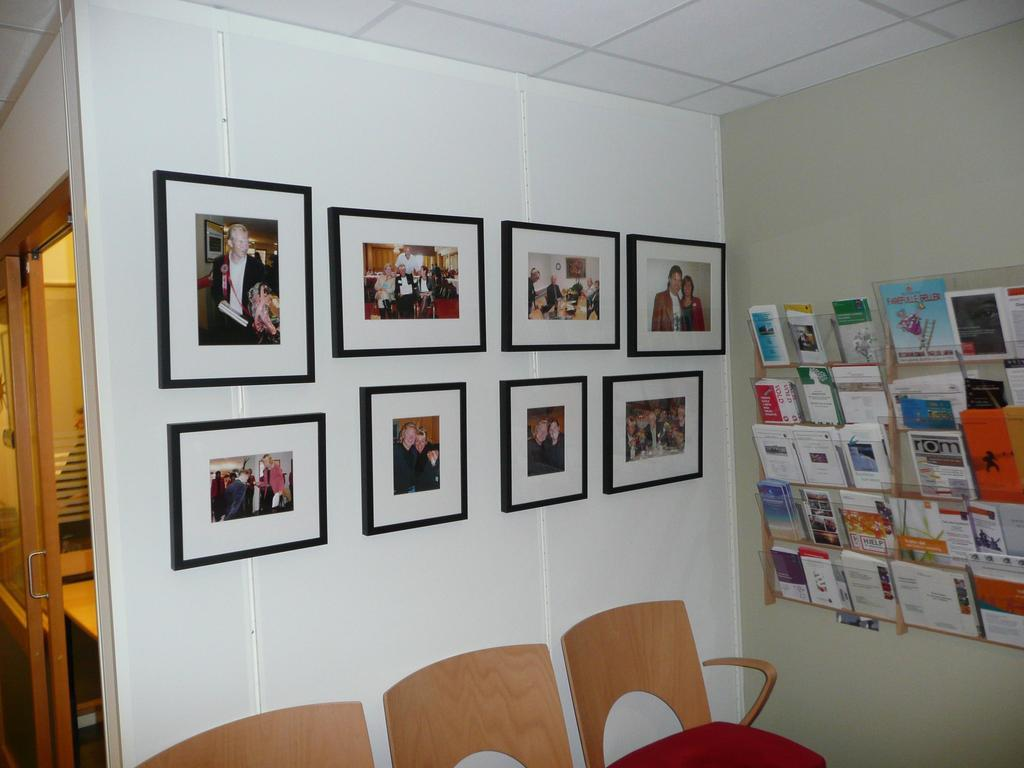What is on the wall in the image? There is a wall with photo frames in the image. What is on the other wall in the image? There is another wall with books in the image. How many chairs are located below the wall with books? There are three chairs below the wall with books. What type of stick can be seen in the mouth of the person in the image? There is no person or stick present in the image. How many corks are visible on the wall with books in the image? There are no corks visible on the wall with books in the image. 